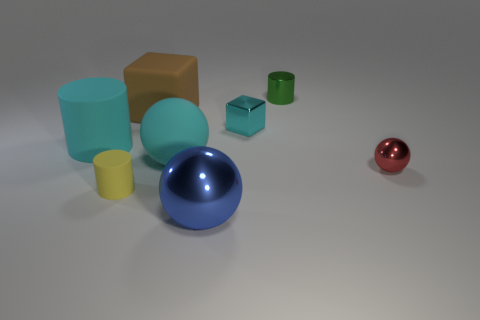There is a metal object that is in front of the small metal sphere; is its shape the same as the tiny object to the right of the green metal cylinder?
Your answer should be compact. Yes. What is the color of the tiny cylinder that is the same material as the big brown object?
Your response must be concise. Yellow. Is the number of large cyan cylinders that are right of the tiny metal cylinder less than the number of large blue cylinders?
Your response must be concise. No. What is the size of the metallic sphere behind the small cylinder that is left of the cylinder on the right side of the yellow cylinder?
Keep it short and to the point. Small. Does the sphere to the right of the big blue metallic thing have the same material as the tiny cube?
Your answer should be very brief. Yes. There is a cylinder that is the same color as the metallic cube; what material is it?
Your answer should be very brief. Rubber. Are there any other things that are the same shape as the small red shiny object?
Make the answer very short. Yes. What number of objects are big shiny cubes or cyan cylinders?
Your response must be concise. 1. What size is the blue metallic thing that is the same shape as the small red shiny object?
Your response must be concise. Large. Is there anything else that is the same size as the brown rubber thing?
Your answer should be compact. Yes. 